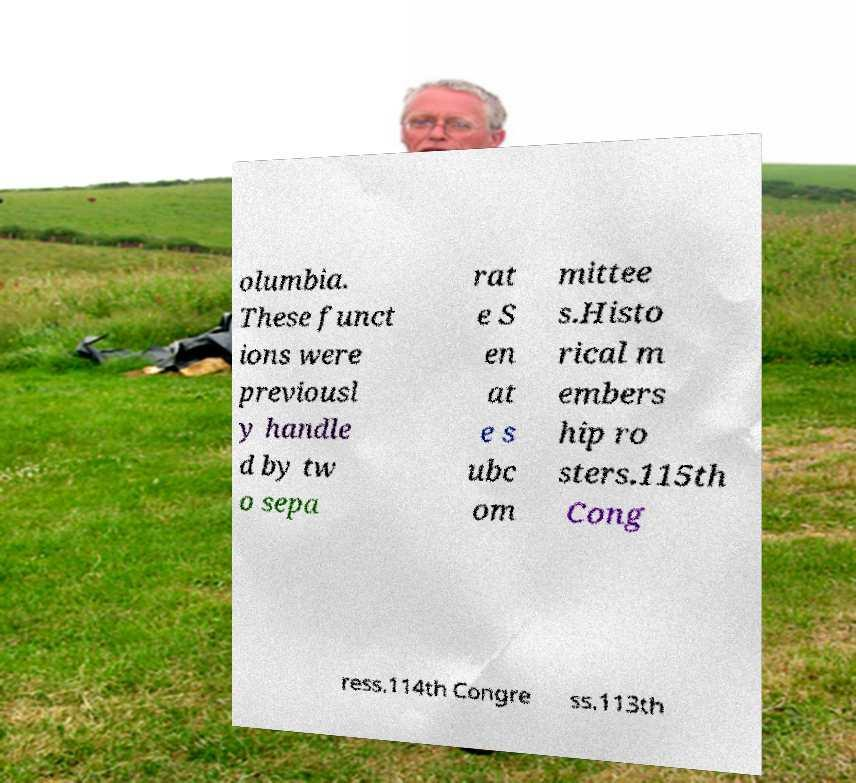I need the written content from this picture converted into text. Can you do that? olumbia. These funct ions were previousl y handle d by tw o sepa rat e S en at e s ubc om mittee s.Histo rical m embers hip ro sters.115th Cong ress.114th Congre ss.113th 